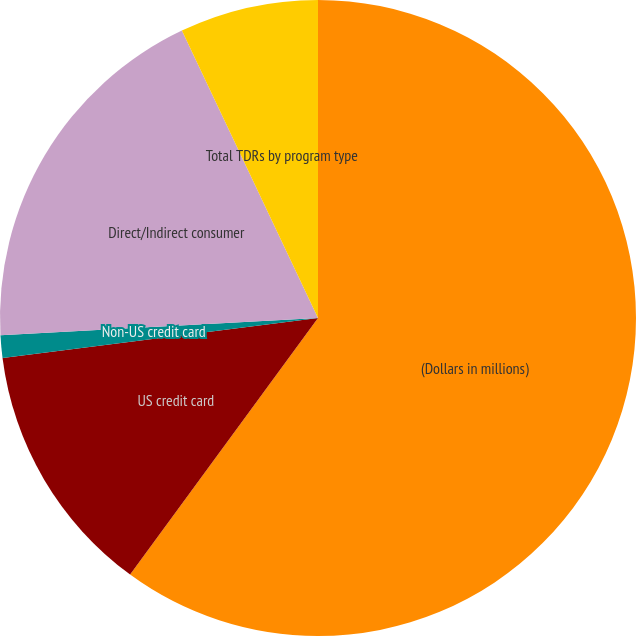Convert chart. <chart><loc_0><loc_0><loc_500><loc_500><pie_chart><fcel>(Dollars in millions)<fcel>US credit card<fcel>Non-US credit card<fcel>Direct/Indirect consumer<fcel>Total TDRs by program type<nl><fcel>60.06%<fcel>12.93%<fcel>1.15%<fcel>18.82%<fcel>7.04%<nl></chart> 